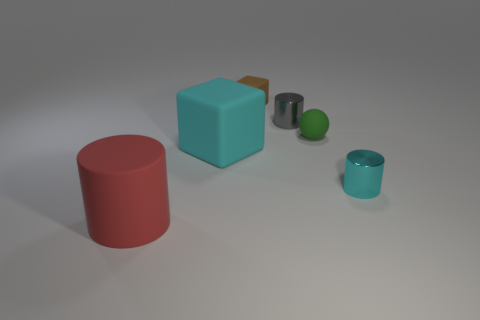The red rubber object that is the same shape as the small cyan object is what size?
Provide a succinct answer. Large. Is there another rubber object of the same shape as the gray thing?
Make the answer very short. Yes. There is a big rubber block; is its color the same as the tiny thing that is in front of the cyan matte object?
Your response must be concise. Yes. There is a object that is the same color as the big rubber block; what is its size?
Your answer should be very brief. Small. Is there a gray metal object of the same size as the brown cube?
Your answer should be very brief. Yes. Does the tiny cyan thing have the same material as the tiny cylinder behind the small matte sphere?
Your answer should be compact. Yes. Are there more big cyan things than metal things?
Offer a terse response. No. How many cylinders are tiny gray metallic things or cyan objects?
Your answer should be compact. 2. The tiny cube has what color?
Provide a succinct answer. Brown. There is a matte block right of the big rubber block; is its size the same as the rubber cube in front of the green sphere?
Your answer should be compact. No. 